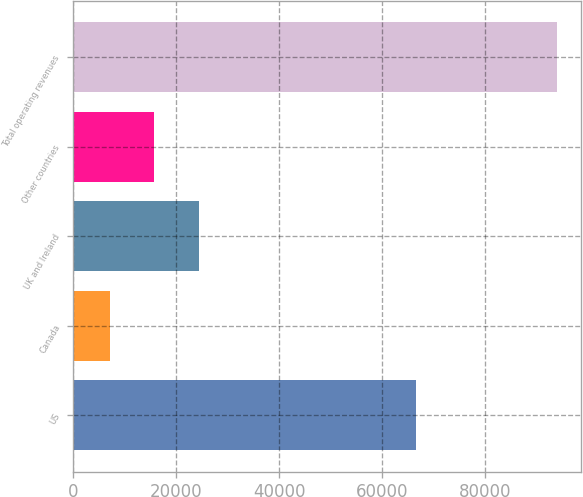Convert chart to OTSL. <chart><loc_0><loc_0><loc_500><loc_500><bar_chart><fcel>US<fcel>Canada<fcel>UK and Ireland<fcel>Other countries<fcel>Total operating revenues<nl><fcel>66614<fcel>7039<fcel>24427.2<fcel>15733.1<fcel>93980<nl></chart> 